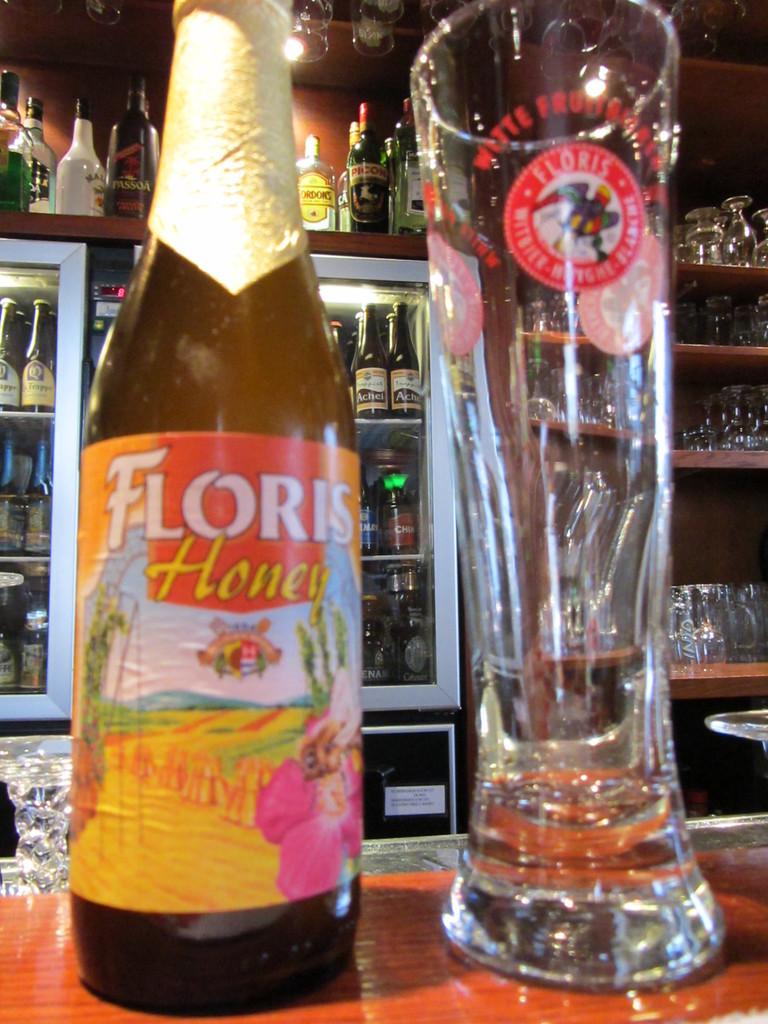What brand of beer is this?
Provide a short and direct response. Floris. 